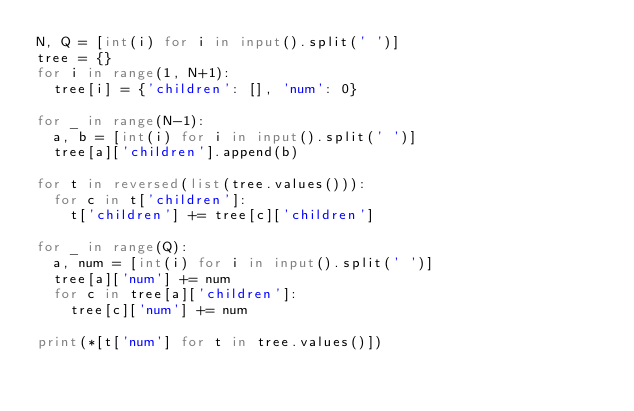<code> <loc_0><loc_0><loc_500><loc_500><_Python_>N, Q = [int(i) for i in input().split(' ')]
tree = {}
for i in range(1, N+1):
  tree[i] = {'children': [], 'num': 0}
  
for _ in range(N-1):
  a, b = [int(i) for i in input().split(' ')]
  tree[a]['children'].append(b)

for t in reversed(list(tree.values())):
  for c in t['children']:
  	t['children'] += tree[c]['children']
    
for _ in range(Q):
  a, num = [int(i) for i in input().split(' ')]
  tree[a]['num'] += num
  for c in tree[a]['children']:
    tree[c]['num'] += num

print(*[t['num'] for t in tree.values()])</code> 